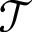Convert formula to latex. <formula><loc_0><loc_0><loc_500><loc_500>\mathcal { T }</formula> 